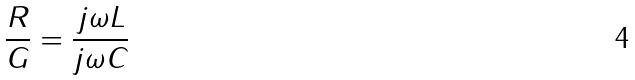Convert formula to latex. <formula><loc_0><loc_0><loc_500><loc_500>\frac { R } { G } = \frac { j \omega L } { j \omega C }</formula> 